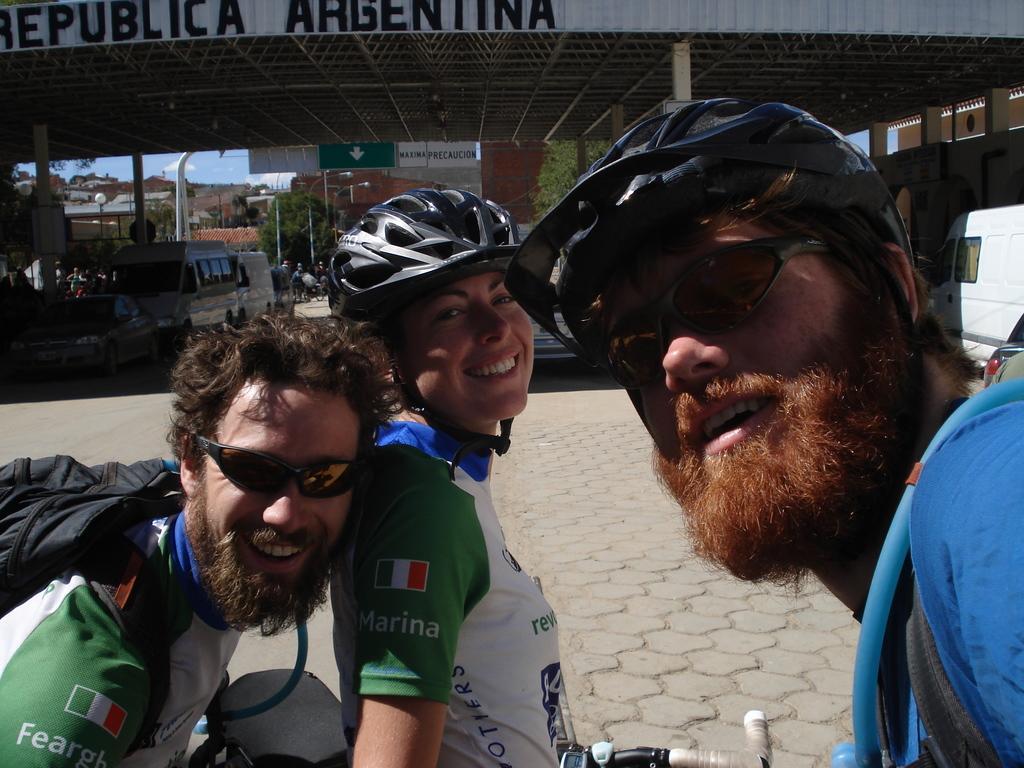Describe this image in one or two sentences. In the foreground of the image there are persons wearing helmets and sunglasses. In the background of the image there is a ceiling with some text. There are vehicles. At the bottom of the image there is floor. 